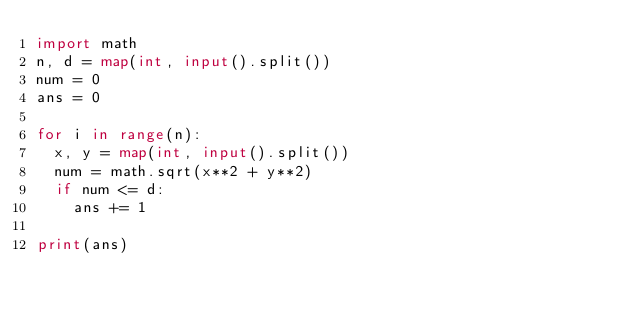Convert code to text. <code><loc_0><loc_0><loc_500><loc_500><_Python_>import math
n, d = map(int, input().split())
num = 0
ans = 0

for i in range(n):
  x, y = map(int, input().split())
  num = math.sqrt(x**2 + y**2)
  if num <= d:
    ans += 1
    
print(ans)</code> 